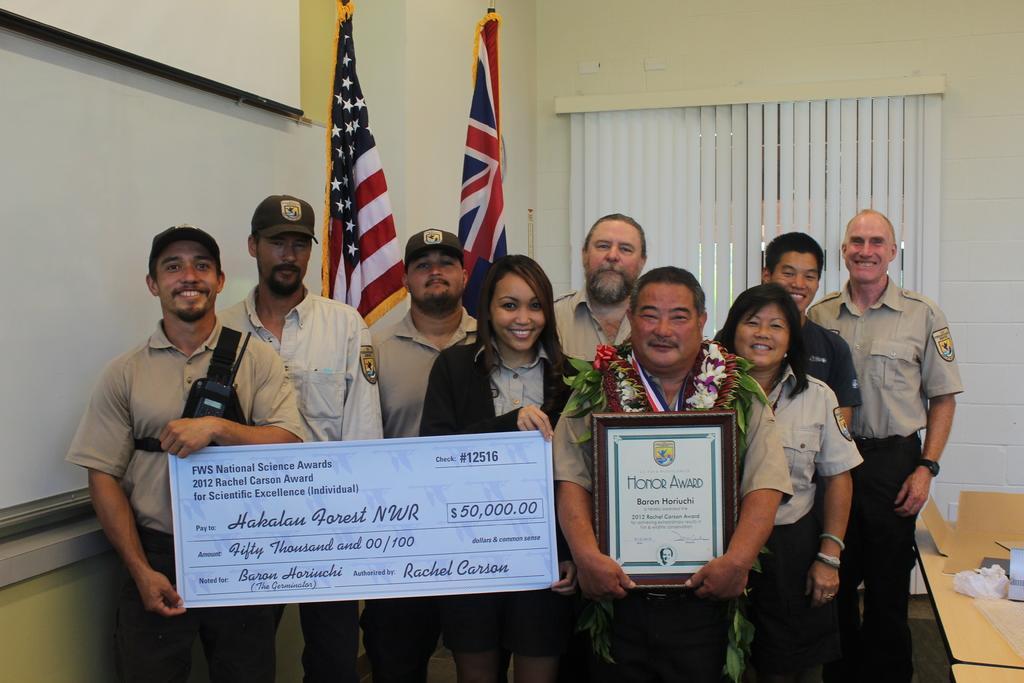Can you describe this image briefly? In this image there are people standing. They are smiling. The man to the left is holding a board. The man to the right is wearing garlands and holding a certificate frame. Behind them are window blinds to the wall. There are flags to the poles. To the left there is a projector board on the wall. To the right there is a table. 